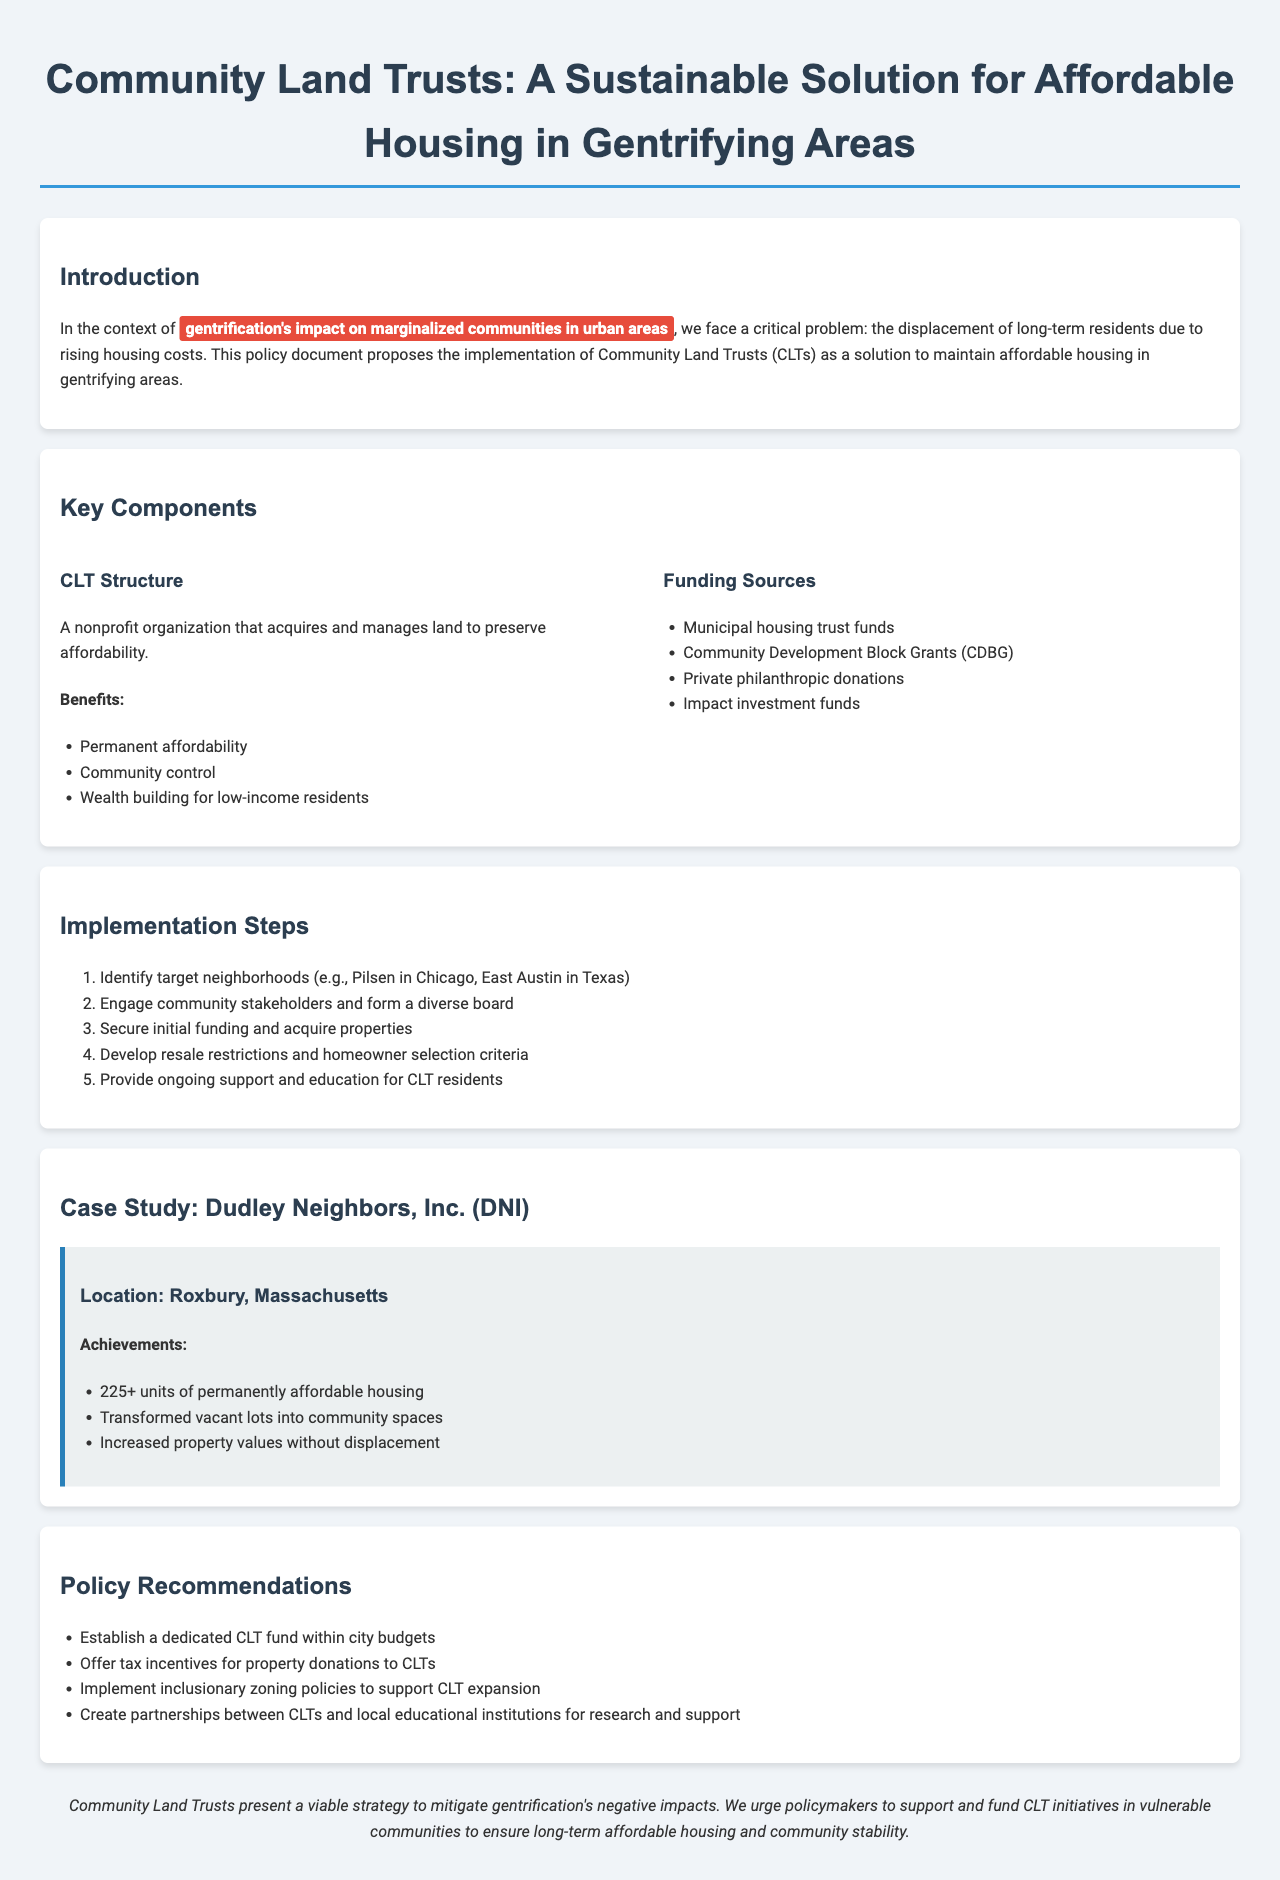what is the primary focus of the document? The primary focus of the document is the implementation of Community Land Trusts to maintain affordable housing in gentrifying areas.
Answer: Community Land Trusts how many implementation steps are provided? The document lists five steps for implementation.
Answer: 5 what are the benefits of the CLT structure? The document lists three benefits: Permanent affordability, Community control, and Wealth building for low-income residents.
Answer: Permanent affordability, Community control, Wealth building for low-income residents name one funding source mentioned. The document includes several funding sources, and one of them is the Community Development Block Grants.
Answer: Community Development Block Grants which organization is used as a case study? The case study referenced in the document is Dudley Neighbors, Inc. (DNI).
Answer: Dudley Neighbors, Inc. (DNI) what is one policy recommendation related to CLTs? One policy recommendation is to offer tax incentives for property donations to CLTs.
Answer: Offer tax incentives for property donations to CLTs where is the location of the case study? The document states that the case study is located in Roxbury, Massachusetts.
Answer: Roxbury, Massachusetts what does the document urge policymakers to do? The document urges policymakers to support and fund CLT initiatives in vulnerable communities.
Answer: Support and fund CLT initiatives 